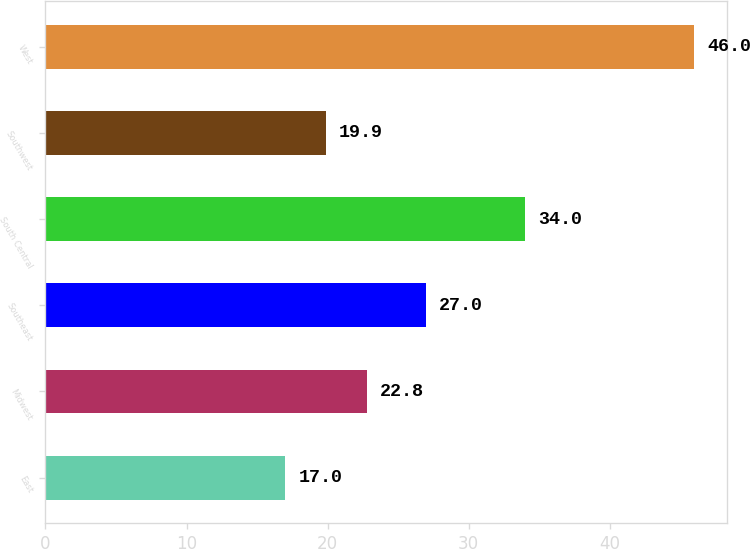Convert chart. <chart><loc_0><loc_0><loc_500><loc_500><bar_chart><fcel>East<fcel>Midwest<fcel>Southeast<fcel>South Central<fcel>Southwest<fcel>West<nl><fcel>17<fcel>22.8<fcel>27<fcel>34<fcel>19.9<fcel>46<nl></chart> 